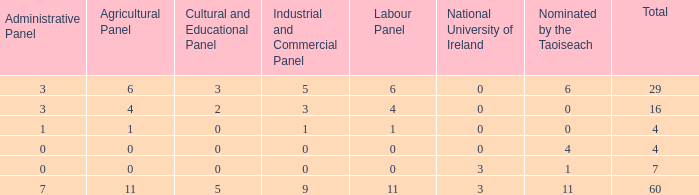What is the largest number of nominee selections by a taoiseach when the composition has an administrative panel count above 0 and an industrial and commercial panel count under 1? None. 